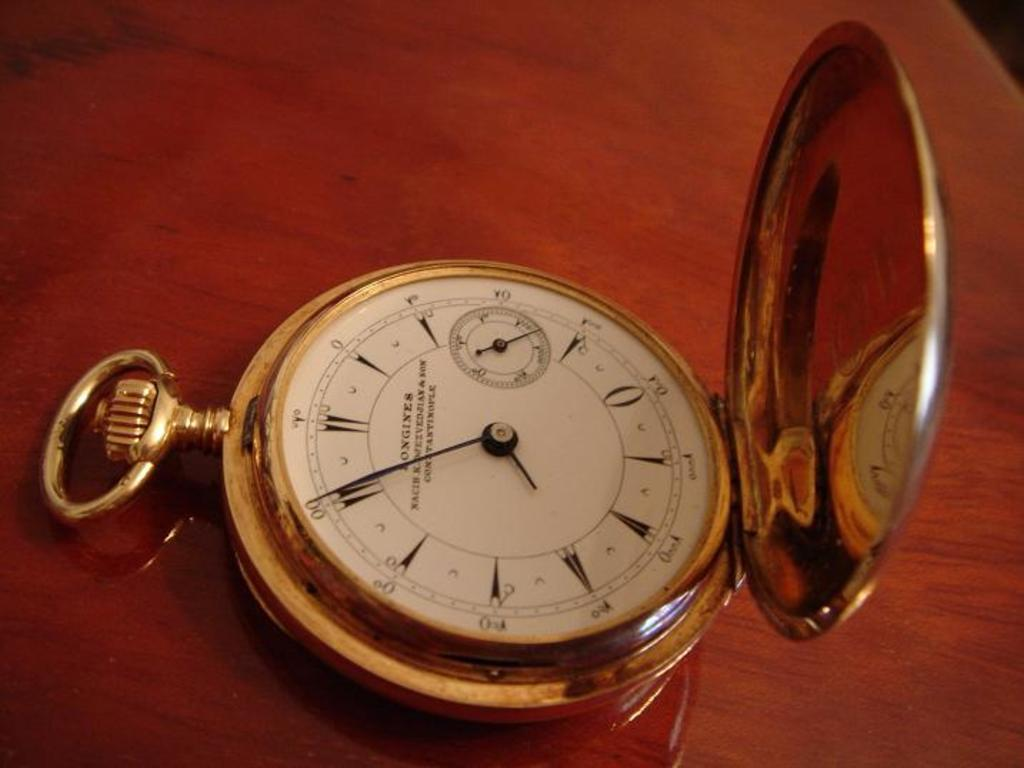<image>
Summarize the visual content of the image. Longines pocket watch with gold case and white face 